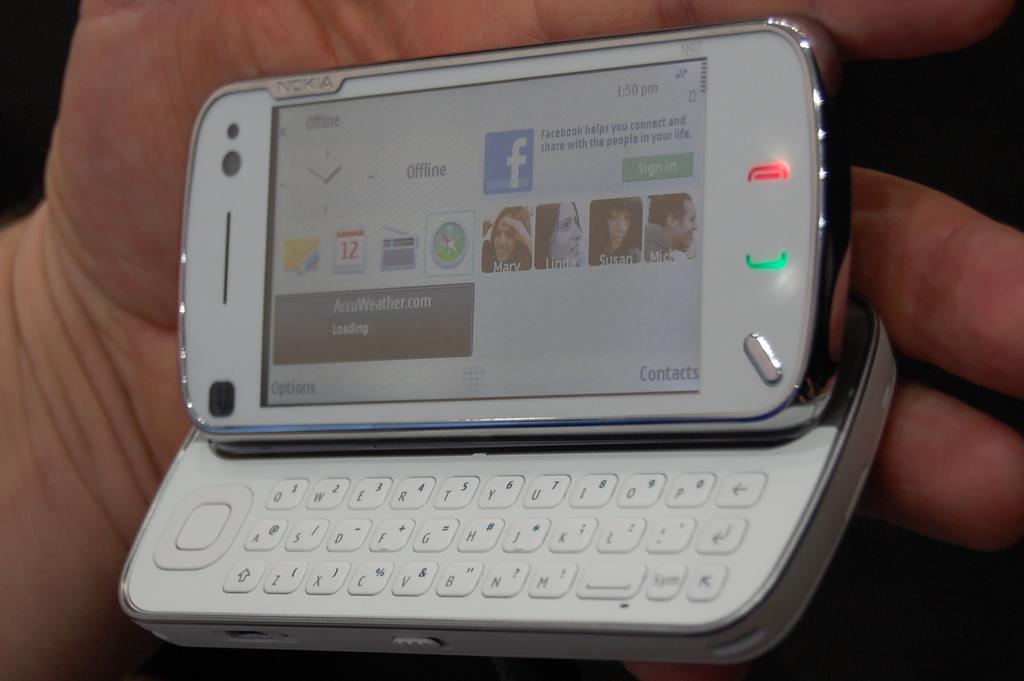What brand is the phone?
Give a very brief answer. Nokia. 